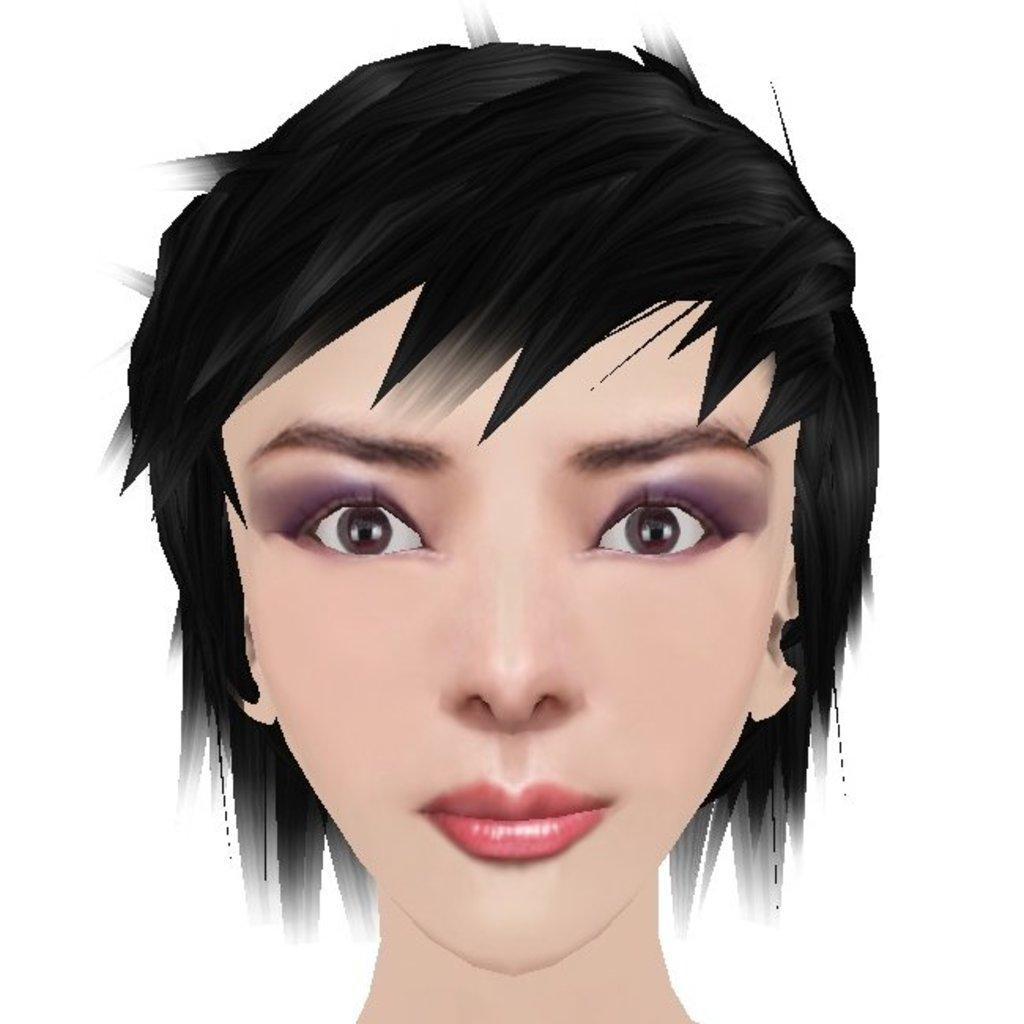What type of image is present in the picture? The image contains an animated picture of a woman. What type of pump can be seen in the image? There is no pump present in the image; it contains an animated picture of a woman. What type of wine is being served in the image? There is no wine or any indication of a beverage being served in the image. 